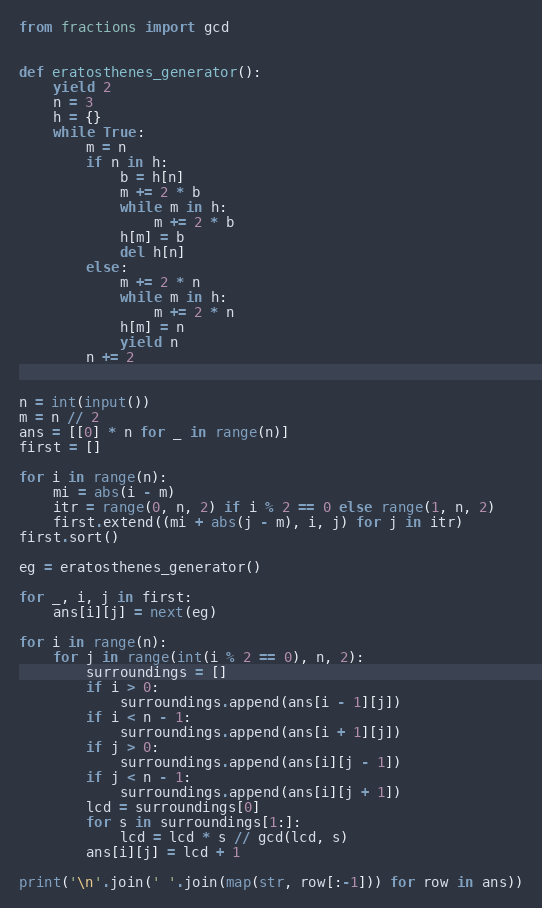Convert code to text. <code><loc_0><loc_0><loc_500><loc_500><_Python_>from fractions import gcd


def eratosthenes_generator():
    yield 2
    n = 3
    h = {}
    while True:
        m = n
        if n in h:
            b = h[n]
            m += 2 * b
            while m in h:
                m += 2 * b
            h[m] = b
            del h[n]
        else:
            m += 2 * n
            while m in h:
                m += 2 * n
            h[m] = n
            yield n
        n += 2


n = int(input())
m = n // 2
ans = [[0] * n for _ in range(n)]
first = []

for i in range(n):
    mi = abs(i - m)
    itr = range(0, n, 2) if i % 2 == 0 else range(1, n, 2)
    first.extend((mi + abs(j - m), i, j) for j in itr)
first.sort()

eg = eratosthenes_generator()

for _, i, j in first:
    ans[i][j] = next(eg)

for i in range(n):
    for j in range(int(i % 2 == 0), n, 2):
        surroundings = []
        if i > 0:
            surroundings.append(ans[i - 1][j])
        if i < n - 1:
            surroundings.append(ans[i + 1][j])
        if j > 0:
            surroundings.append(ans[i][j - 1])
        if j < n - 1:
            surroundings.append(ans[i][j + 1])
        lcd = surroundings[0]
        for s in surroundings[1:]:
            lcd = lcd * s // gcd(lcd, s)
        ans[i][j] = lcd + 1

print('\n'.join(' '.join(map(str, row[:-1])) for row in ans))
</code> 